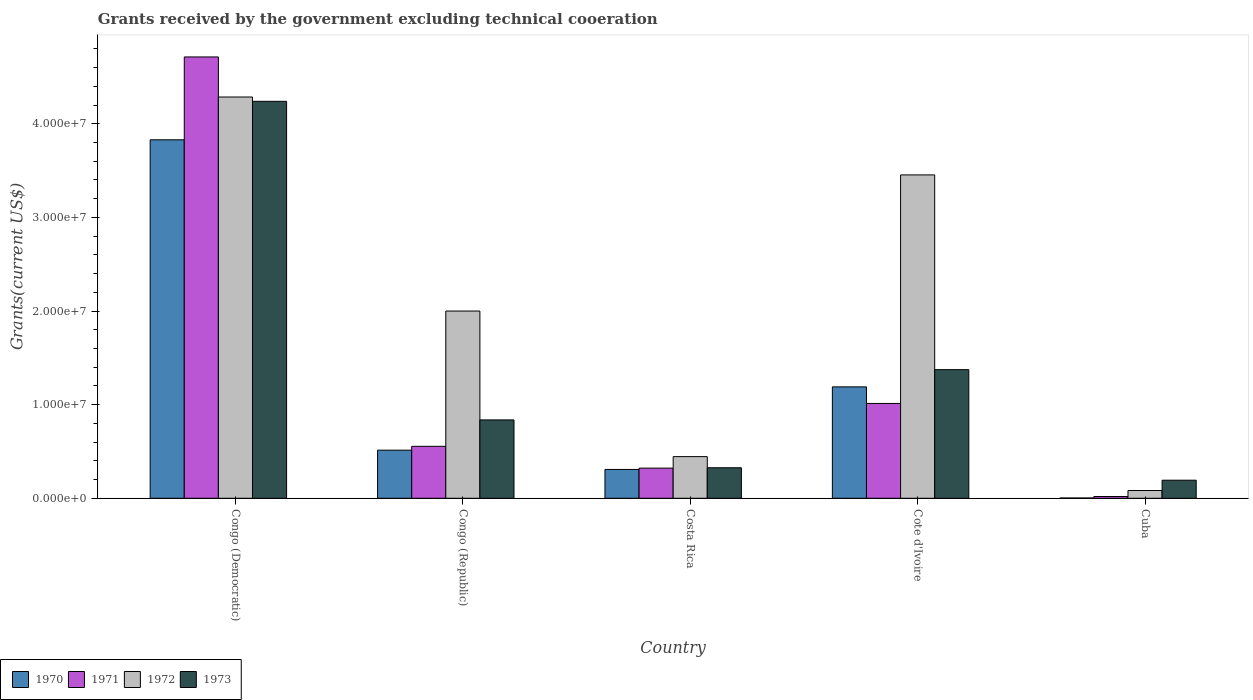Are the number of bars per tick equal to the number of legend labels?
Offer a very short reply. Yes. What is the label of the 1st group of bars from the left?
Give a very brief answer. Congo (Democratic). In how many cases, is the number of bars for a given country not equal to the number of legend labels?
Offer a very short reply. 0. What is the total grants received by the government in 1971 in Cote d'Ivoire?
Make the answer very short. 1.01e+07. Across all countries, what is the maximum total grants received by the government in 1970?
Make the answer very short. 3.83e+07. In which country was the total grants received by the government in 1971 maximum?
Provide a succinct answer. Congo (Democratic). In which country was the total grants received by the government in 1972 minimum?
Your answer should be compact. Cuba. What is the total total grants received by the government in 1973 in the graph?
Your response must be concise. 6.97e+07. What is the difference between the total grants received by the government in 1971 in Congo (Republic) and that in Costa Rica?
Give a very brief answer. 2.33e+06. What is the difference between the total grants received by the government in 1972 in Congo (Democratic) and the total grants received by the government in 1970 in Congo (Republic)?
Make the answer very short. 3.77e+07. What is the average total grants received by the government in 1973 per country?
Give a very brief answer. 1.39e+07. What is the difference between the total grants received by the government of/in 1970 and total grants received by the government of/in 1973 in Congo (Republic)?
Your response must be concise. -3.23e+06. In how many countries, is the total grants received by the government in 1972 greater than 6000000 US$?
Keep it short and to the point. 3. What is the ratio of the total grants received by the government in 1973 in Congo (Democratic) to that in Cuba?
Your answer should be very brief. 21.97. Is the total grants received by the government in 1971 in Congo (Democratic) less than that in Congo (Republic)?
Your answer should be very brief. No. Is the difference between the total grants received by the government in 1970 in Costa Rica and Cote d'Ivoire greater than the difference between the total grants received by the government in 1973 in Costa Rica and Cote d'Ivoire?
Your answer should be very brief. Yes. What is the difference between the highest and the second highest total grants received by the government in 1972?
Give a very brief answer. 2.29e+07. What is the difference between the highest and the lowest total grants received by the government in 1972?
Give a very brief answer. 4.20e+07. In how many countries, is the total grants received by the government in 1970 greater than the average total grants received by the government in 1970 taken over all countries?
Provide a succinct answer. 2. What does the 1st bar from the left in Cote d'Ivoire represents?
Ensure brevity in your answer.  1970. Is it the case that in every country, the sum of the total grants received by the government in 1973 and total grants received by the government in 1971 is greater than the total grants received by the government in 1970?
Offer a very short reply. Yes. How many bars are there?
Keep it short and to the point. 20. Are all the bars in the graph horizontal?
Offer a very short reply. No. How many countries are there in the graph?
Give a very brief answer. 5. Are the values on the major ticks of Y-axis written in scientific E-notation?
Keep it short and to the point. Yes. How many legend labels are there?
Give a very brief answer. 4. How are the legend labels stacked?
Keep it short and to the point. Horizontal. What is the title of the graph?
Your answer should be compact. Grants received by the government excluding technical cooeration. What is the label or title of the Y-axis?
Offer a terse response. Grants(current US$). What is the Grants(current US$) in 1970 in Congo (Democratic)?
Provide a succinct answer. 3.83e+07. What is the Grants(current US$) of 1971 in Congo (Democratic)?
Your answer should be compact. 4.71e+07. What is the Grants(current US$) in 1972 in Congo (Democratic)?
Your answer should be very brief. 4.29e+07. What is the Grants(current US$) in 1973 in Congo (Democratic)?
Provide a succinct answer. 4.24e+07. What is the Grants(current US$) in 1970 in Congo (Republic)?
Your answer should be compact. 5.14e+06. What is the Grants(current US$) of 1971 in Congo (Republic)?
Your answer should be compact. 5.55e+06. What is the Grants(current US$) of 1972 in Congo (Republic)?
Make the answer very short. 2.00e+07. What is the Grants(current US$) of 1973 in Congo (Republic)?
Keep it short and to the point. 8.37e+06. What is the Grants(current US$) of 1970 in Costa Rica?
Ensure brevity in your answer.  3.08e+06. What is the Grants(current US$) of 1971 in Costa Rica?
Give a very brief answer. 3.22e+06. What is the Grants(current US$) of 1972 in Costa Rica?
Your answer should be compact. 4.45e+06. What is the Grants(current US$) of 1973 in Costa Rica?
Offer a very short reply. 3.26e+06. What is the Grants(current US$) of 1970 in Cote d'Ivoire?
Your answer should be very brief. 1.19e+07. What is the Grants(current US$) of 1971 in Cote d'Ivoire?
Provide a succinct answer. 1.01e+07. What is the Grants(current US$) in 1972 in Cote d'Ivoire?
Keep it short and to the point. 3.45e+07. What is the Grants(current US$) of 1973 in Cote d'Ivoire?
Ensure brevity in your answer.  1.37e+07. What is the Grants(current US$) of 1970 in Cuba?
Make the answer very short. 3.00e+04. What is the Grants(current US$) of 1971 in Cuba?
Give a very brief answer. 1.90e+05. What is the Grants(current US$) in 1972 in Cuba?
Your response must be concise. 8.30e+05. What is the Grants(current US$) in 1973 in Cuba?
Make the answer very short. 1.93e+06. Across all countries, what is the maximum Grants(current US$) in 1970?
Your answer should be very brief. 3.83e+07. Across all countries, what is the maximum Grants(current US$) in 1971?
Make the answer very short. 4.71e+07. Across all countries, what is the maximum Grants(current US$) of 1972?
Your answer should be very brief. 4.29e+07. Across all countries, what is the maximum Grants(current US$) in 1973?
Your answer should be very brief. 4.24e+07. Across all countries, what is the minimum Grants(current US$) of 1970?
Keep it short and to the point. 3.00e+04. Across all countries, what is the minimum Grants(current US$) of 1971?
Give a very brief answer. 1.90e+05. Across all countries, what is the minimum Grants(current US$) of 1972?
Provide a succinct answer. 8.30e+05. Across all countries, what is the minimum Grants(current US$) in 1973?
Offer a very short reply. 1.93e+06. What is the total Grants(current US$) in 1970 in the graph?
Keep it short and to the point. 5.84e+07. What is the total Grants(current US$) in 1971 in the graph?
Your answer should be very brief. 6.62e+07. What is the total Grants(current US$) in 1972 in the graph?
Your answer should be very brief. 1.03e+08. What is the total Grants(current US$) of 1973 in the graph?
Provide a short and direct response. 6.97e+07. What is the difference between the Grants(current US$) in 1970 in Congo (Democratic) and that in Congo (Republic)?
Your answer should be compact. 3.32e+07. What is the difference between the Grants(current US$) in 1971 in Congo (Democratic) and that in Congo (Republic)?
Offer a terse response. 4.16e+07. What is the difference between the Grants(current US$) in 1972 in Congo (Democratic) and that in Congo (Republic)?
Provide a succinct answer. 2.29e+07. What is the difference between the Grants(current US$) in 1973 in Congo (Democratic) and that in Congo (Republic)?
Ensure brevity in your answer.  3.40e+07. What is the difference between the Grants(current US$) in 1970 in Congo (Democratic) and that in Costa Rica?
Offer a terse response. 3.52e+07. What is the difference between the Grants(current US$) of 1971 in Congo (Democratic) and that in Costa Rica?
Provide a short and direct response. 4.39e+07. What is the difference between the Grants(current US$) of 1972 in Congo (Democratic) and that in Costa Rica?
Your response must be concise. 3.84e+07. What is the difference between the Grants(current US$) in 1973 in Congo (Democratic) and that in Costa Rica?
Ensure brevity in your answer.  3.91e+07. What is the difference between the Grants(current US$) of 1970 in Congo (Democratic) and that in Cote d'Ivoire?
Your answer should be very brief. 2.64e+07. What is the difference between the Grants(current US$) in 1971 in Congo (Democratic) and that in Cote d'Ivoire?
Provide a succinct answer. 3.70e+07. What is the difference between the Grants(current US$) in 1972 in Congo (Democratic) and that in Cote d'Ivoire?
Keep it short and to the point. 8.32e+06. What is the difference between the Grants(current US$) of 1973 in Congo (Democratic) and that in Cote d'Ivoire?
Offer a terse response. 2.87e+07. What is the difference between the Grants(current US$) of 1970 in Congo (Democratic) and that in Cuba?
Give a very brief answer. 3.83e+07. What is the difference between the Grants(current US$) in 1971 in Congo (Democratic) and that in Cuba?
Your answer should be compact. 4.70e+07. What is the difference between the Grants(current US$) of 1972 in Congo (Democratic) and that in Cuba?
Offer a terse response. 4.20e+07. What is the difference between the Grants(current US$) of 1973 in Congo (Democratic) and that in Cuba?
Make the answer very short. 4.05e+07. What is the difference between the Grants(current US$) in 1970 in Congo (Republic) and that in Costa Rica?
Offer a very short reply. 2.06e+06. What is the difference between the Grants(current US$) of 1971 in Congo (Republic) and that in Costa Rica?
Ensure brevity in your answer.  2.33e+06. What is the difference between the Grants(current US$) in 1972 in Congo (Republic) and that in Costa Rica?
Your answer should be compact. 1.56e+07. What is the difference between the Grants(current US$) in 1973 in Congo (Republic) and that in Costa Rica?
Offer a terse response. 5.11e+06. What is the difference between the Grants(current US$) of 1970 in Congo (Republic) and that in Cote d'Ivoire?
Provide a short and direct response. -6.76e+06. What is the difference between the Grants(current US$) of 1971 in Congo (Republic) and that in Cote d'Ivoire?
Make the answer very short. -4.58e+06. What is the difference between the Grants(current US$) in 1972 in Congo (Republic) and that in Cote d'Ivoire?
Offer a terse response. -1.45e+07. What is the difference between the Grants(current US$) in 1973 in Congo (Republic) and that in Cote d'Ivoire?
Give a very brief answer. -5.37e+06. What is the difference between the Grants(current US$) in 1970 in Congo (Republic) and that in Cuba?
Keep it short and to the point. 5.11e+06. What is the difference between the Grants(current US$) in 1971 in Congo (Republic) and that in Cuba?
Provide a short and direct response. 5.36e+06. What is the difference between the Grants(current US$) of 1972 in Congo (Republic) and that in Cuba?
Your answer should be compact. 1.92e+07. What is the difference between the Grants(current US$) in 1973 in Congo (Republic) and that in Cuba?
Your answer should be compact. 6.44e+06. What is the difference between the Grants(current US$) of 1970 in Costa Rica and that in Cote d'Ivoire?
Ensure brevity in your answer.  -8.82e+06. What is the difference between the Grants(current US$) in 1971 in Costa Rica and that in Cote d'Ivoire?
Offer a very short reply. -6.91e+06. What is the difference between the Grants(current US$) in 1972 in Costa Rica and that in Cote d'Ivoire?
Keep it short and to the point. -3.01e+07. What is the difference between the Grants(current US$) of 1973 in Costa Rica and that in Cote d'Ivoire?
Make the answer very short. -1.05e+07. What is the difference between the Grants(current US$) in 1970 in Costa Rica and that in Cuba?
Offer a terse response. 3.05e+06. What is the difference between the Grants(current US$) in 1971 in Costa Rica and that in Cuba?
Provide a succinct answer. 3.03e+06. What is the difference between the Grants(current US$) in 1972 in Costa Rica and that in Cuba?
Ensure brevity in your answer.  3.62e+06. What is the difference between the Grants(current US$) of 1973 in Costa Rica and that in Cuba?
Your response must be concise. 1.33e+06. What is the difference between the Grants(current US$) in 1970 in Cote d'Ivoire and that in Cuba?
Keep it short and to the point. 1.19e+07. What is the difference between the Grants(current US$) of 1971 in Cote d'Ivoire and that in Cuba?
Offer a terse response. 9.94e+06. What is the difference between the Grants(current US$) in 1972 in Cote d'Ivoire and that in Cuba?
Offer a terse response. 3.37e+07. What is the difference between the Grants(current US$) of 1973 in Cote d'Ivoire and that in Cuba?
Make the answer very short. 1.18e+07. What is the difference between the Grants(current US$) of 1970 in Congo (Democratic) and the Grants(current US$) of 1971 in Congo (Republic)?
Offer a very short reply. 3.27e+07. What is the difference between the Grants(current US$) of 1970 in Congo (Democratic) and the Grants(current US$) of 1972 in Congo (Republic)?
Ensure brevity in your answer.  1.83e+07. What is the difference between the Grants(current US$) in 1970 in Congo (Democratic) and the Grants(current US$) in 1973 in Congo (Republic)?
Ensure brevity in your answer.  2.99e+07. What is the difference between the Grants(current US$) in 1971 in Congo (Democratic) and the Grants(current US$) in 1972 in Congo (Republic)?
Make the answer very short. 2.71e+07. What is the difference between the Grants(current US$) in 1971 in Congo (Democratic) and the Grants(current US$) in 1973 in Congo (Republic)?
Keep it short and to the point. 3.88e+07. What is the difference between the Grants(current US$) in 1972 in Congo (Democratic) and the Grants(current US$) in 1973 in Congo (Republic)?
Offer a very short reply. 3.45e+07. What is the difference between the Grants(current US$) in 1970 in Congo (Democratic) and the Grants(current US$) in 1971 in Costa Rica?
Provide a succinct answer. 3.51e+07. What is the difference between the Grants(current US$) in 1970 in Congo (Democratic) and the Grants(current US$) in 1972 in Costa Rica?
Ensure brevity in your answer.  3.38e+07. What is the difference between the Grants(current US$) of 1970 in Congo (Democratic) and the Grants(current US$) of 1973 in Costa Rica?
Offer a very short reply. 3.50e+07. What is the difference between the Grants(current US$) of 1971 in Congo (Democratic) and the Grants(current US$) of 1972 in Costa Rica?
Offer a very short reply. 4.27e+07. What is the difference between the Grants(current US$) of 1971 in Congo (Democratic) and the Grants(current US$) of 1973 in Costa Rica?
Keep it short and to the point. 4.39e+07. What is the difference between the Grants(current US$) in 1972 in Congo (Democratic) and the Grants(current US$) in 1973 in Costa Rica?
Your answer should be compact. 3.96e+07. What is the difference between the Grants(current US$) of 1970 in Congo (Democratic) and the Grants(current US$) of 1971 in Cote d'Ivoire?
Your answer should be compact. 2.82e+07. What is the difference between the Grants(current US$) in 1970 in Congo (Democratic) and the Grants(current US$) in 1972 in Cote d'Ivoire?
Make the answer very short. 3.75e+06. What is the difference between the Grants(current US$) in 1970 in Congo (Democratic) and the Grants(current US$) in 1973 in Cote d'Ivoire?
Offer a terse response. 2.46e+07. What is the difference between the Grants(current US$) in 1971 in Congo (Democratic) and the Grants(current US$) in 1972 in Cote d'Ivoire?
Ensure brevity in your answer.  1.26e+07. What is the difference between the Grants(current US$) in 1971 in Congo (Democratic) and the Grants(current US$) in 1973 in Cote d'Ivoire?
Your answer should be very brief. 3.34e+07. What is the difference between the Grants(current US$) of 1972 in Congo (Democratic) and the Grants(current US$) of 1973 in Cote d'Ivoire?
Your response must be concise. 2.91e+07. What is the difference between the Grants(current US$) of 1970 in Congo (Democratic) and the Grants(current US$) of 1971 in Cuba?
Your answer should be compact. 3.81e+07. What is the difference between the Grants(current US$) of 1970 in Congo (Democratic) and the Grants(current US$) of 1972 in Cuba?
Offer a very short reply. 3.75e+07. What is the difference between the Grants(current US$) of 1970 in Congo (Democratic) and the Grants(current US$) of 1973 in Cuba?
Give a very brief answer. 3.64e+07. What is the difference between the Grants(current US$) in 1971 in Congo (Democratic) and the Grants(current US$) in 1972 in Cuba?
Make the answer very short. 4.63e+07. What is the difference between the Grants(current US$) of 1971 in Congo (Democratic) and the Grants(current US$) of 1973 in Cuba?
Provide a short and direct response. 4.52e+07. What is the difference between the Grants(current US$) in 1972 in Congo (Democratic) and the Grants(current US$) in 1973 in Cuba?
Ensure brevity in your answer.  4.09e+07. What is the difference between the Grants(current US$) of 1970 in Congo (Republic) and the Grants(current US$) of 1971 in Costa Rica?
Your response must be concise. 1.92e+06. What is the difference between the Grants(current US$) of 1970 in Congo (Republic) and the Grants(current US$) of 1972 in Costa Rica?
Give a very brief answer. 6.90e+05. What is the difference between the Grants(current US$) in 1970 in Congo (Republic) and the Grants(current US$) in 1973 in Costa Rica?
Keep it short and to the point. 1.88e+06. What is the difference between the Grants(current US$) of 1971 in Congo (Republic) and the Grants(current US$) of 1972 in Costa Rica?
Offer a terse response. 1.10e+06. What is the difference between the Grants(current US$) of 1971 in Congo (Republic) and the Grants(current US$) of 1973 in Costa Rica?
Offer a terse response. 2.29e+06. What is the difference between the Grants(current US$) in 1972 in Congo (Republic) and the Grants(current US$) in 1973 in Costa Rica?
Your response must be concise. 1.67e+07. What is the difference between the Grants(current US$) in 1970 in Congo (Republic) and the Grants(current US$) in 1971 in Cote d'Ivoire?
Keep it short and to the point. -4.99e+06. What is the difference between the Grants(current US$) in 1970 in Congo (Republic) and the Grants(current US$) in 1972 in Cote d'Ivoire?
Keep it short and to the point. -2.94e+07. What is the difference between the Grants(current US$) in 1970 in Congo (Republic) and the Grants(current US$) in 1973 in Cote d'Ivoire?
Give a very brief answer. -8.60e+06. What is the difference between the Grants(current US$) of 1971 in Congo (Republic) and the Grants(current US$) of 1972 in Cote d'Ivoire?
Offer a very short reply. -2.90e+07. What is the difference between the Grants(current US$) of 1971 in Congo (Republic) and the Grants(current US$) of 1973 in Cote d'Ivoire?
Give a very brief answer. -8.19e+06. What is the difference between the Grants(current US$) in 1972 in Congo (Republic) and the Grants(current US$) in 1973 in Cote d'Ivoire?
Ensure brevity in your answer.  6.26e+06. What is the difference between the Grants(current US$) in 1970 in Congo (Republic) and the Grants(current US$) in 1971 in Cuba?
Keep it short and to the point. 4.95e+06. What is the difference between the Grants(current US$) of 1970 in Congo (Republic) and the Grants(current US$) of 1972 in Cuba?
Offer a terse response. 4.31e+06. What is the difference between the Grants(current US$) of 1970 in Congo (Republic) and the Grants(current US$) of 1973 in Cuba?
Ensure brevity in your answer.  3.21e+06. What is the difference between the Grants(current US$) of 1971 in Congo (Republic) and the Grants(current US$) of 1972 in Cuba?
Offer a very short reply. 4.72e+06. What is the difference between the Grants(current US$) in 1971 in Congo (Republic) and the Grants(current US$) in 1973 in Cuba?
Make the answer very short. 3.62e+06. What is the difference between the Grants(current US$) in 1972 in Congo (Republic) and the Grants(current US$) in 1973 in Cuba?
Give a very brief answer. 1.81e+07. What is the difference between the Grants(current US$) of 1970 in Costa Rica and the Grants(current US$) of 1971 in Cote d'Ivoire?
Your answer should be compact. -7.05e+06. What is the difference between the Grants(current US$) in 1970 in Costa Rica and the Grants(current US$) in 1972 in Cote d'Ivoire?
Offer a very short reply. -3.15e+07. What is the difference between the Grants(current US$) in 1970 in Costa Rica and the Grants(current US$) in 1973 in Cote d'Ivoire?
Your answer should be compact. -1.07e+07. What is the difference between the Grants(current US$) in 1971 in Costa Rica and the Grants(current US$) in 1972 in Cote d'Ivoire?
Make the answer very short. -3.13e+07. What is the difference between the Grants(current US$) of 1971 in Costa Rica and the Grants(current US$) of 1973 in Cote d'Ivoire?
Provide a short and direct response. -1.05e+07. What is the difference between the Grants(current US$) in 1972 in Costa Rica and the Grants(current US$) in 1973 in Cote d'Ivoire?
Make the answer very short. -9.29e+06. What is the difference between the Grants(current US$) of 1970 in Costa Rica and the Grants(current US$) of 1971 in Cuba?
Offer a very short reply. 2.89e+06. What is the difference between the Grants(current US$) in 1970 in Costa Rica and the Grants(current US$) in 1972 in Cuba?
Offer a terse response. 2.25e+06. What is the difference between the Grants(current US$) in 1970 in Costa Rica and the Grants(current US$) in 1973 in Cuba?
Provide a short and direct response. 1.15e+06. What is the difference between the Grants(current US$) in 1971 in Costa Rica and the Grants(current US$) in 1972 in Cuba?
Offer a very short reply. 2.39e+06. What is the difference between the Grants(current US$) of 1971 in Costa Rica and the Grants(current US$) of 1973 in Cuba?
Provide a succinct answer. 1.29e+06. What is the difference between the Grants(current US$) of 1972 in Costa Rica and the Grants(current US$) of 1973 in Cuba?
Your answer should be compact. 2.52e+06. What is the difference between the Grants(current US$) of 1970 in Cote d'Ivoire and the Grants(current US$) of 1971 in Cuba?
Provide a succinct answer. 1.17e+07. What is the difference between the Grants(current US$) in 1970 in Cote d'Ivoire and the Grants(current US$) in 1972 in Cuba?
Your answer should be compact. 1.11e+07. What is the difference between the Grants(current US$) in 1970 in Cote d'Ivoire and the Grants(current US$) in 1973 in Cuba?
Your response must be concise. 9.97e+06. What is the difference between the Grants(current US$) in 1971 in Cote d'Ivoire and the Grants(current US$) in 1972 in Cuba?
Offer a terse response. 9.30e+06. What is the difference between the Grants(current US$) of 1971 in Cote d'Ivoire and the Grants(current US$) of 1973 in Cuba?
Your answer should be compact. 8.20e+06. What is the difference between the Grants(current US$) of 1972 in Cote d'Ivoire and the Grants(current US$) of 1973 in Cuba?
Provide a succinct answer. 3.26e+07. What is the average Grants(current US$) in 1970 per country?
Provide a succinct answer. 1.17e+07. What is the average Grants(current US$) of 1971 per country?
Provide a succinct answer. 1.32e+07. What is the average Grants(current US$) of 1972 per country?
Offer a terse response. 2.05e+07. What is the average Grants(current US$) in 1973 per country?
Keep it short and to the point. 1.39e+07. What is the difference between the Grants(current US$) of 1970 and Grants(current US$) of 1971 in Congo (Democratic)?
Give a very brief answer. -8.85e+06. What is the difference between the Grants(current US$) in 1970 and Grants(current US$) in 1972 in Congo (Democratic)?
Keep it short and to the point. -4.57e+06. What is the difference between the Grants(current US$) in 1970 and Grants(current US$) in 1973 in Congo (Democratic)?
Your response must be concise. -4.11e+06. What is the difference between the Grants(current US$) in 1971 and Grants(current US$) in 1972 in Congo (Democratic)?
Keep it short and to the point. 4.28e+06. What is the difference between the Grants(current US$) of 1971 and Grants(current US$) of 1973 in Congo (Democratic)?
Keep it short and to the point. 4.74e+06. What is the difference between the Grants(current US$) in 1970 and Grants(current US$) in 1971 in Congo (Republic)?
Your answer should be very brief. -4.10e+05. What is the difference between the Grants(current US$) in 1970 and Grants(current US$) in 1972 in Congo (Republic)?
Your answer should be compact. -1.49e+07. What is the difference between the Grants(current US$) of 1970 and Grants(current US$) of 1973 in Congo (Republic)?
Offer a very short reply. -3.23e+06. What is the difference between the Grants(current US$) in 1971 and Grants(current US$) in 1972 in Congo (Republic)?
Provide a succinct answer. -1.44e+07. What is the difference between the Grants(current US$) of 1971 and Grants(current US$) of 1973 in Congo (Republic)?
Your answer should be very brief. -2.82e+06. What is the difference between the Grants(current US$) in 1972 and Grants(current US$) in 1973 in Congo (Republic)?
Give a very brief answer. 1.16e+07. What is the difference between the Grants(current US$) in 1970 and Grants(current US$) in 1972 in Costa Rica?
Offer a terse response. -1.37e+06. What is the difference between the Grants(current US$) in 1970 and Grants(current US$) in 1973 in Costa Rica?
Make the answer very short. -1.80e+05. What is the difference between the Grants(current US$) in 1971 and Grants(current US$) in 1972 in Costa Rica?
Your response must be concise. -1.23e+06. What is the difference between the Grants(current US$) of 1971 and Grants(current US$) of 1973 in Costa Rica?
Provide a short and direct response. -4.00e+04. What is the difference between the Grants(current US$) of 1972 and Grants(current US$) of 1973 in Costa Rica?
Make the answer very short. 1.19e+06. What is the difference between the Grants(current US$) in 1970 and Grants(current US$) in 1971 in Cote d'Ivoire?
Offer a very short reply. 1.77e+06. What is the difference between the Grants(current US$) of 1970 and Grants(current US$) of 1972 in Cote d'Ivoire?
Offer a terse response. -2.26e+07. What is the difference between the Grants(current US$) of 1970 and Grants(current US$) of 1973 in Cote d'Ivoire?
Ensure brevity in your answer.  -1.84e+06. What is the difference between the Grants(current US$) of 1971 and Grants(current US$) of 1972 in Cote d'Ivoire?
Give a very brief answer. -2.44e+07. What is the difference between the Grants(current US$) of 1971 and Grants(current US$) of 1973 in Cote d'Ivoire?
Your response must be concise. -3.61e+06. What is the difference between the Grants(current US$) of 1972 and Grants(current US$) of 1973 in Cote d'Ivoire?
Offer a very short reply. 2.08e+07. What is the difference between the Grants(current US$) of 1970 and Grants(current US$) of 1972 in Cuba?
Offer a terse response. -8.00e+05. What is the difference between the Grants(current US$) in 1970 and Grants(current US$) in 1973 in Cuba?
Your answer should be very brief. -1.90e+06. What is the difference between the Grants(current US$) in 1971 and Grants(current US$) in 1972 in Cuba?
Your answer should be very brief. -6.40e+05. What is the difference between the Grants(current US$) of 1971 and Grants(current US$) of 1973 in Cuba?
Your response must be concise. -1.74e+06. What is the difference between the Grants(current US$) in 1972 and Grants(current US$) in 1973 in Cuba?
Give a very brief answer. -1.10e+06. What is the ratio of the Grants(current US$) in 1970 in Congo (Democratic) to that in Congo (Republic)?
Your answer should be compact. 7.45. What is the ratio of the Grants(current US$) in 1971 in Congo (Democratic) to that in Congo (Republic)?
Keep it short and to the point. 8.49. What is the ratio of the Grants(current US$) in 1972 in Congo (Democratic) to that in Congo (Republic)?
Make the answer very short. 2.14. What is the ratio of the Grants(current US$) of 1973 in Congo (Democratic) to that in Congo (Republic)?
Ensure brevity in your answer.  5.07. What is the ratio of the Grants(current US$) in 1970 in Congo (Democratic) to that in Costa Rica?
Offer a very short reply. 12.43. What is the ratio of the Grants(current US$) in 1971 in Congo (Democratic) to that in Costa Rica?
Give a very brief answer. 14.64. What is the ratio of the Grants(current US$) of 1972 in Congo (Democratic) to that in Costa Rica?
Provide a succinct answer. 9.63. What is the ratio of the Grants(current US$) in 1973 in Congo (Democratic) to that in Costa Rica?
Your answer should be compact. 13.01. What is the ratio of the Grants(current US$) in 1970 in Congo (Democratic) to that in Cote d'Ivoire?
Ensure brevity in your answer.  3.22. What is the ratio of the Grants(current US$) in 1971 in Congo (Democratic) to that in Cote d'Ivoire?
Make the answer very short. 4.65. What is the ratio of the Grants(current US$) of 1972 in Congo (Democratic) to that in Cote d'Ivoire?
Your answer should be very brief. 1.24. What is the ratio of the Grants(current US$) in 1973 in Congo (Democratic) to that in Cote d'Ivoire?
Keep it short and to the point. 3.09. What is the ratio of the Grants(current US$) in 1970 in Congo (Democratic) to that in Cuba?
Offer a terse response. 1276.33. What is the ratio of the Grants(current US$) of 1971 in Congo (Democratic) to that in Cuba?
Provide a short and direct response. 248.11. What is the ratio of the Grants(current US$) of 1972 in Congo (Democratic) to that in Cuba?
Offer a very short reply. 51.64. What is the ratio of the Grants(current US$) in 1973 in Congo (Democratic) to that in Cuba?
Offer a very short reply. 21.97. What is the ratio of the Grants(current US$) in 1970 in Congo (Republic) to that in Costa Rica?
Give a very brief answer. 1.67. What is the ratio of the Grants(current US$) of 1971 in Congo (Republic) to that in Costa Rica?
Provide a short and direct response. 1.72. What is the ratio of the Grants(current US$) in 1972 in Congo (Republic) to that in Costa Rica?
Provide a succinct answer. 4.49. What is the ratio of the Grants(current US$) in 1973 in Congo (Republic) to that in Costa Rica?
Your response must be concise. 2.57. What is the ratio of the Grants(current US$) of 1970 in Congo (Republic) to that in Cote d'Ivoire?
Keep it short and to the point. 0.43. What is the ratio of the Grants(current US$) of 1971 in Congo (Republic) to that in Cote d'Ivoire?
Provide a short and direct response. 0.55. What is the ratio of the Grants(current US$) in 1972 in Congo (Republic) to that in Cote d'Ivoire?
Offer a terse response. 0.58. What is the ratio of the Grants(current US$) in 1973 in Congo (Republic) to that in Cote d'Ivoire?
Make the answer very short. 0.61. What is the ratio of the Grants(current US$) of 1970 in Congo (Republic) to that in Cuba?
Your response must be concise. 171.33. What is the ratio of the Grants(current US$) in 1971 in Congo (Republic) to that in Cuba?
Offer a terse response. 29.21. What is the ratio of the Grants(current US$) of 1972 in Congo (Republic) to that in Cuba?
Give a very brief answer. 24.1. What is the ratio of the Grants(current US$) in 1973 in Congo (Republic) to that in Cuba?
Ensure brevity in your answer.  4.34. What is the ratio of the Grants(current US$) of 1970 in Costa Rica to that in Cote d'Ivoire?
Your answer should be compact. 0.26. What is the ratio of the Grants(current US$) of 1971 in Costa Rica to that in Cote d'Ivoire?
Offer a terse response. 0.32. What is the ratio of the Grants(current US$) in 1972 in Costa Rica to that in Cote d'Ivoire?
Provide a succinct answer. 0.13. What is the ratio of the Grants(current US$) of 1973 in Costa Rica to that in Cote d'Ivoire?
Your answer should be very brief. 0.24. What is the ratio of the Grants(current US$) in 1970 in Costa Rica to that in Cuba?
Ensure brevity in your answer.  102.67. What is the ratio of the Grants(current US$) in 1971 in Costa Rica to that in Cuba?
Your response must be concise. 16.95. What is the ratio of the Grants(current US$) in 1972 in Costa Rica to that in Cuba?
Keep it short and to the point. 5.36. What is the ratio of the Grants(current US$) of 1973 in Costa Rica to that in Cuba?
Offer a terse response. 1.69. What is the ratio of the Grants(current US$) of 1970 in Cote d'Ivoire to that in Cuba?
Provide a succinct answer. 396.67. What is the ratio of the Grants(current US$) in 1971 in Cote d'Ivoire to that in Cuba?
Provide a short and direct response. 53.32. What is the ratio of the Grants(current US$) of 1972 in Cote d'Ivoire to that in Cuba?
Provide a succinct answer. 41.61. What is the ratio of the Grants(current US$) in 1973 in Cote d'Ivoire to that in Cuba?
Your response must be concise. 7.12. What is the difference between the highest and the second highest Grants(current US$) of 1970?
Your answer should be compact. 2.64e+07. What is the difference between the highest and the second highest Grants(current US$) in 1971?
Your answer should be compact. 3.70e+07. What is the difference between the highest and the second highest Grants(current US$) in 1972?
Give a very brief answer. 8.32e+06. What is the difference between the highest and the second highest Grants(current US$) in 1973?
Provide a short and direct response. 2.87e+07. What is the difference between the highest and the lowest Grants(current US$) of 1970?
Offer a terse response. 3.83e+07. What is the difference between the highest and the lowest Grants(current US$) in 1971?
Offer a terse response. 4.70e+07. What is the difference between the highest and the lowest Grants(current US$) in 1972?
Make the answer very short. 4.20e+07. What is the difference between the highest and the lowest Grants(current US$) in 1973?
Ensure brevity in your answer.  4.05e+07. 